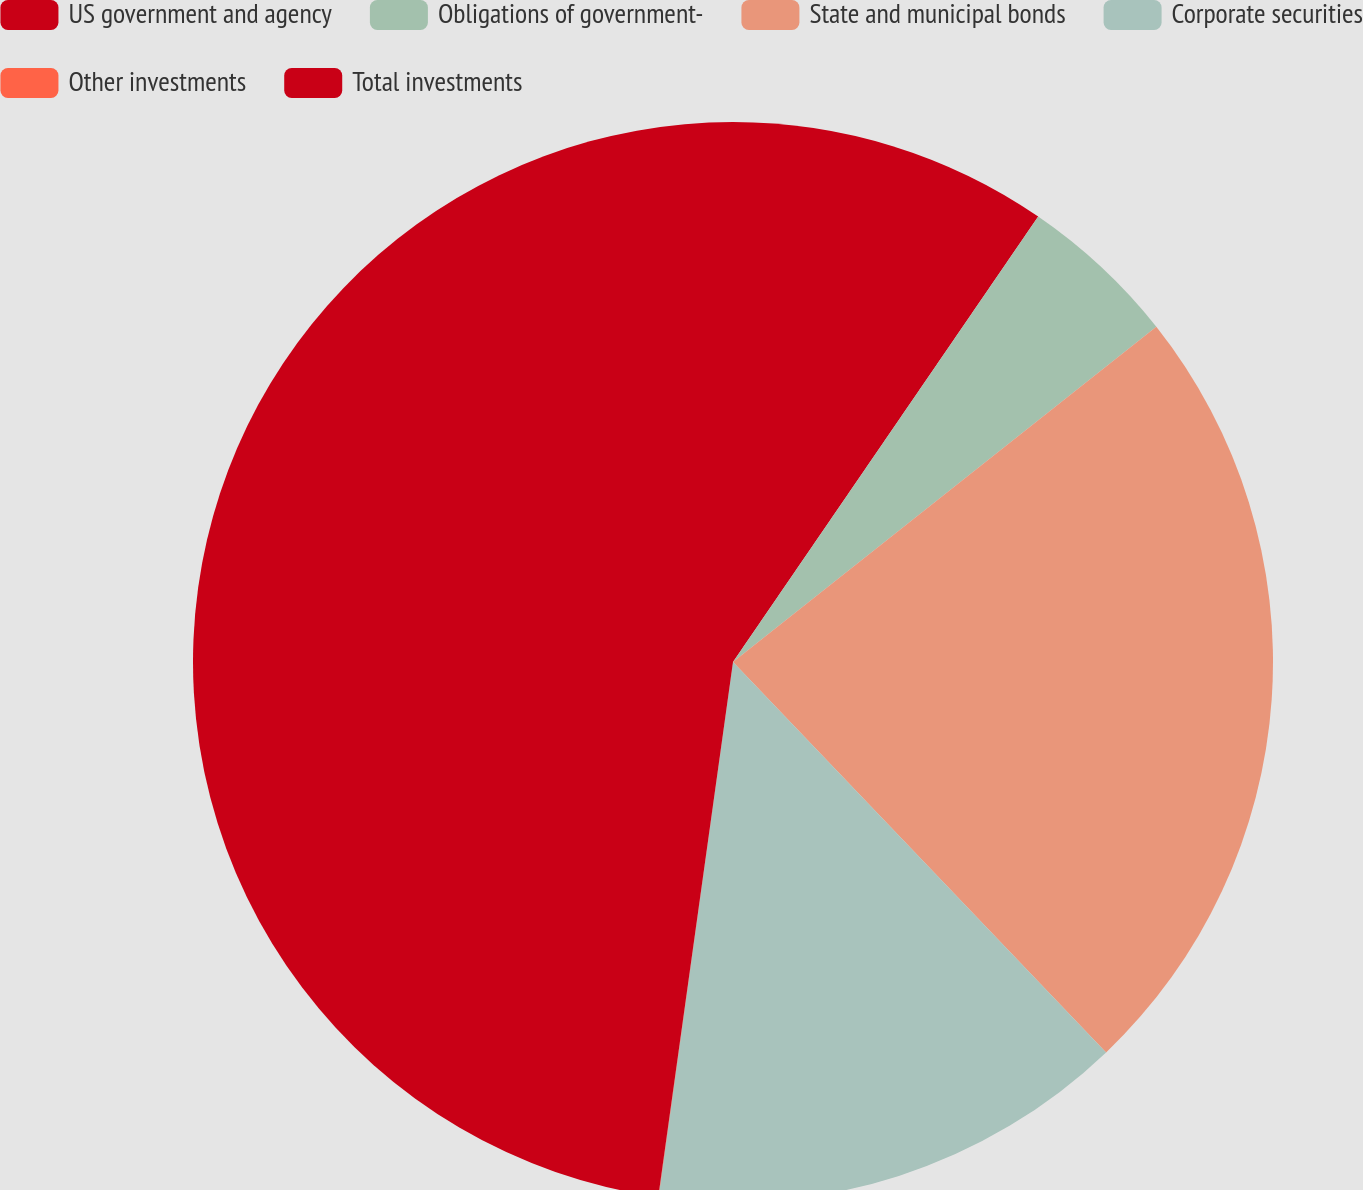<chart> <loc_0><loc_0><loc_500><loc_500><pie_chart><fcel>US government and agency<fcel>Obligations of government-<fcel>State and municipal bonds<fcel>Corporate securities<fcel>Other investments<fcel>Total investments<nl><fcel>9.56%<fcel>4.78%<fcel>23.52%<fcel>14.34%<fcel>0.01%<fcel>47.79%<nl></chart> 